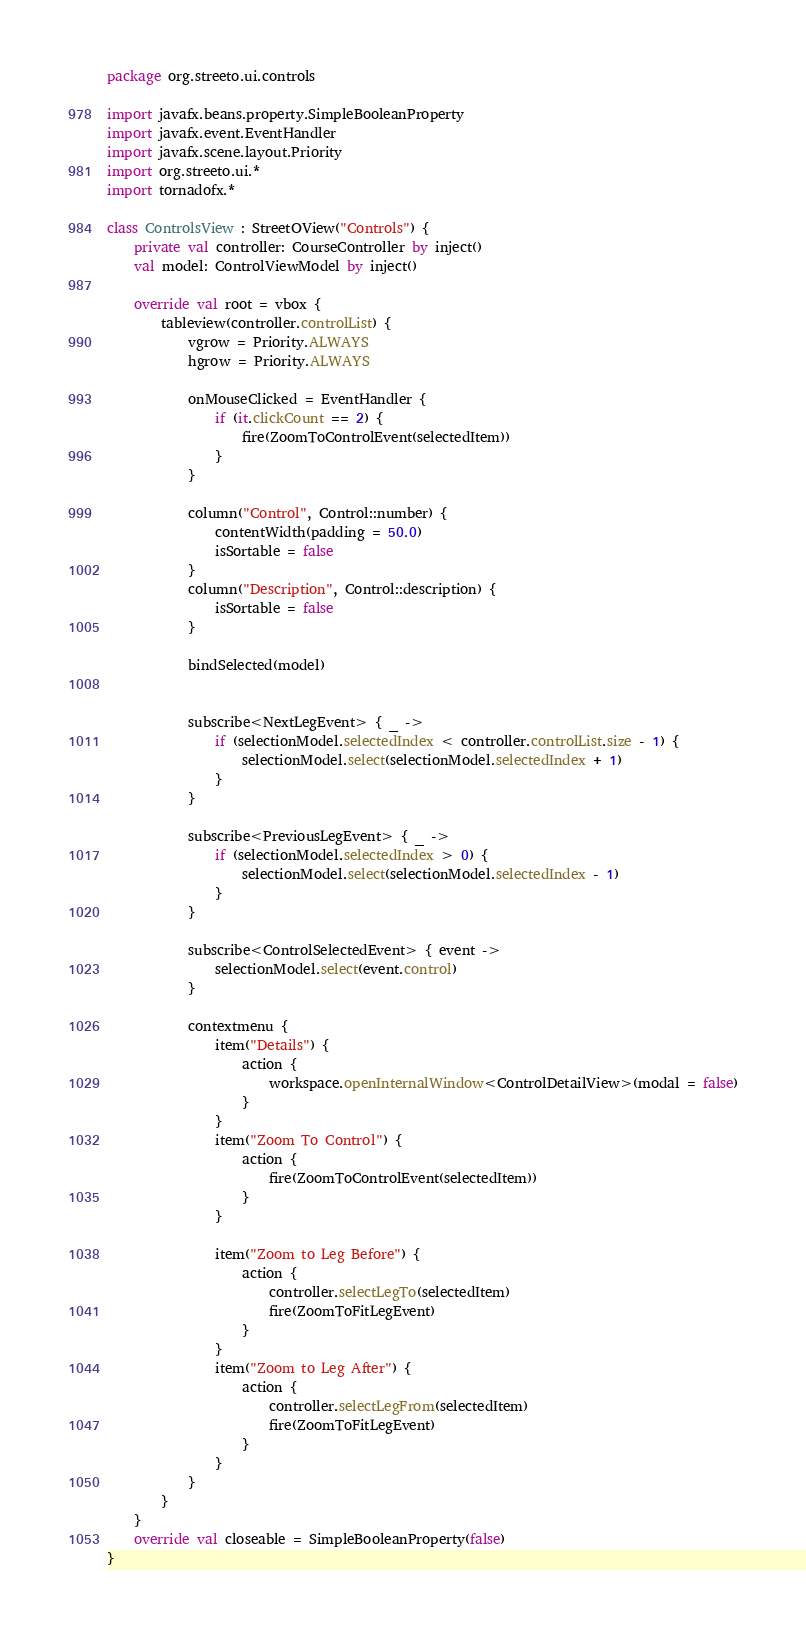<code> <loc_0><loc_0><loc_500><loc_500><_Kotlin_>package org.streeto.ui.controls

import javafx.beans.property.SimpleBooleanProperty
import javafx.event.EventHandler
import javafx.scene.layout.Priority
import org.streeto.ui.*
import tornadofx.*

class ControlsView : StreetOView("Controls") {
    private val controller: CourseController by inject()
    val model: ControlViewModel by inject()

    override val root = vbox {
        tableview(controller.controlList) {
            vgrow = Priority.ALWAYS
            hgrow = Priority.ALWAYS

            onMouseClicked = EventHandler {
                if (it.clickCount == 2) {
                    fire(ZoomToControlEvent(selectedItem))
                }
            }

            column("Control", Control::number) {
                contentWidth(padding = 50.0)
                isSortable = false
            }
            column("Description", Control::description) {
                isSortable = false
            }

            bindSelected(model)


            subscribe<NextLegEvent> { _ ->
                if (selectionModel.selectedIndex < controller.controlList.size - 1) {
                    selectionModel.select(selectionModel.selectedIndex + 1)
                }
            }

            subscribe<PreviousLegEvent> { _ ->
                if (selectionModel.selectedIndex > 0) {
                    selectionModel.select(selectionModel.selectedIndex - 1)
                }
            }

            subscribe<ControlSelectedEvent> { event ->
                selectionModel.select(event.control)
            }

            contextmenu {
                item("Details") {
                    action {
                        workspace.openInternalWindow<ControlDetailView>(modal = false)
                    }
                }
                item("Zoom To Control") {
                    action {
                        fire(ZoomToControlEvent(selectedItem))
                    }
                }

                item("Zoom to Leg Before") {
                    action {
                        controller.selectLegTo(selectedItem)
                        fire(ZoomToFitLegEvent)
                    }
                }
                item("Zoom to Leg After") {
                    action {
                        controller.selectLegFrom(selectedItem)
                        fire(ZoomToFitLegEvent)
                    }
                }
            }
        }
    }
    override val closeable = SimpleBooleanProperty(false)
}</code> 